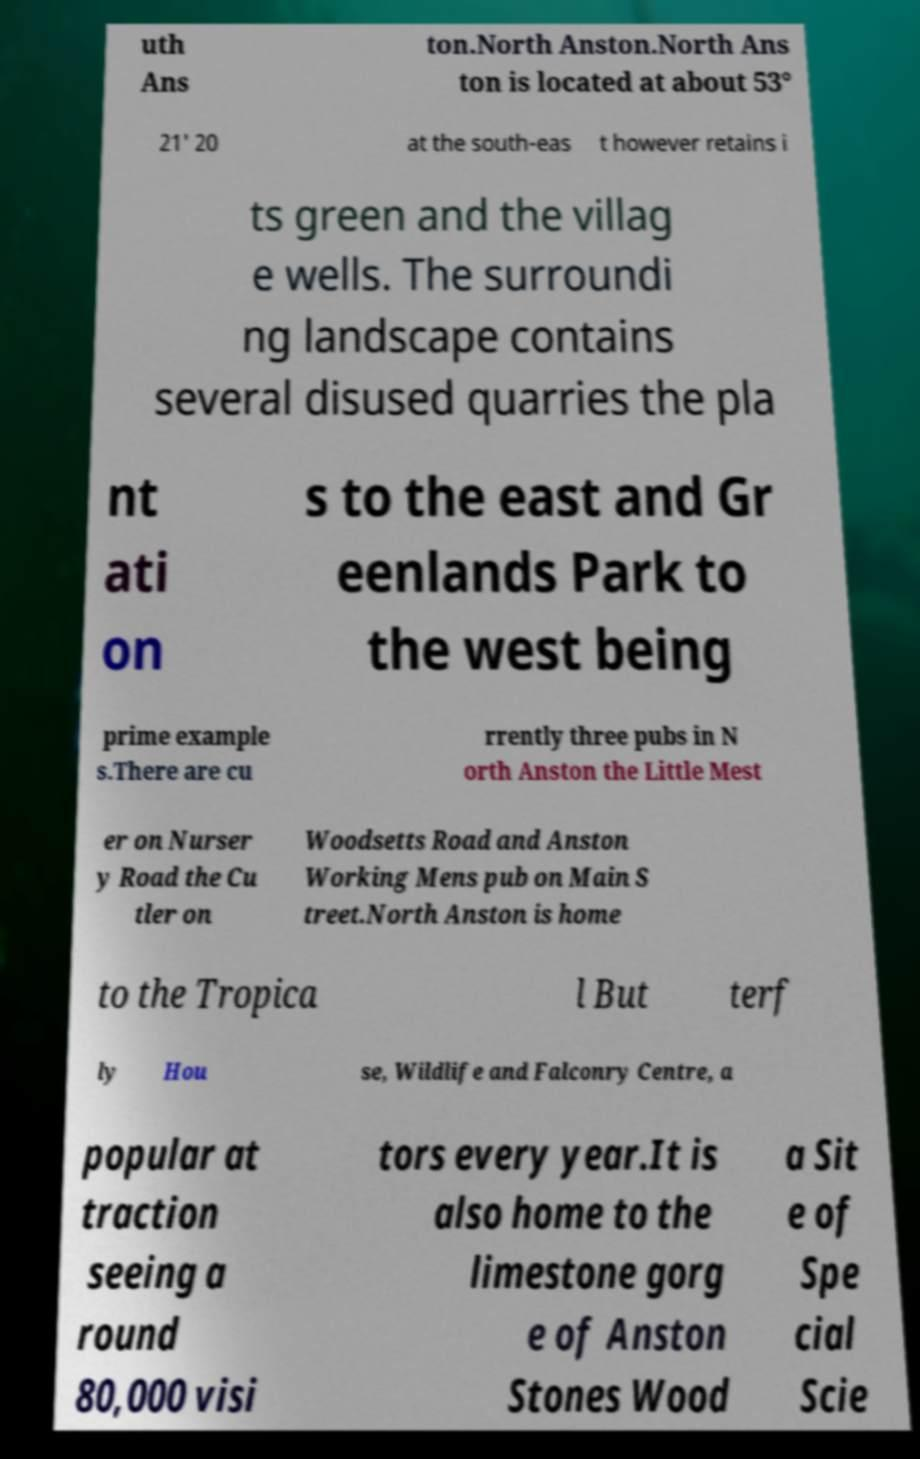Could you extract and type out the text from this image? uth Ans ton.North Anston.North Ans ton is located at about 53° 21' 20 at the south-eas t however retains i ts green and the villag e wells. The surroundi ng landscape contains several disused quarries the pla nt ati on s to the east and Gr eenlands Park to the west being prime example s.There are cu rrently three pubs in N orth Anston the Little Mest er on Nurser y Road the Cu tler on Woodsetts Road and Anston Working Mens pub on Main S treet.North Anston is home to the Tropica l But terf ly Hou se, Wildlife and Falconry Centre, a popular at traction seeing a round 80,000 visi tors every year.It is also home to the limestone gorg e of Anston Stones Wood a Sit e of Spe cial Scie 